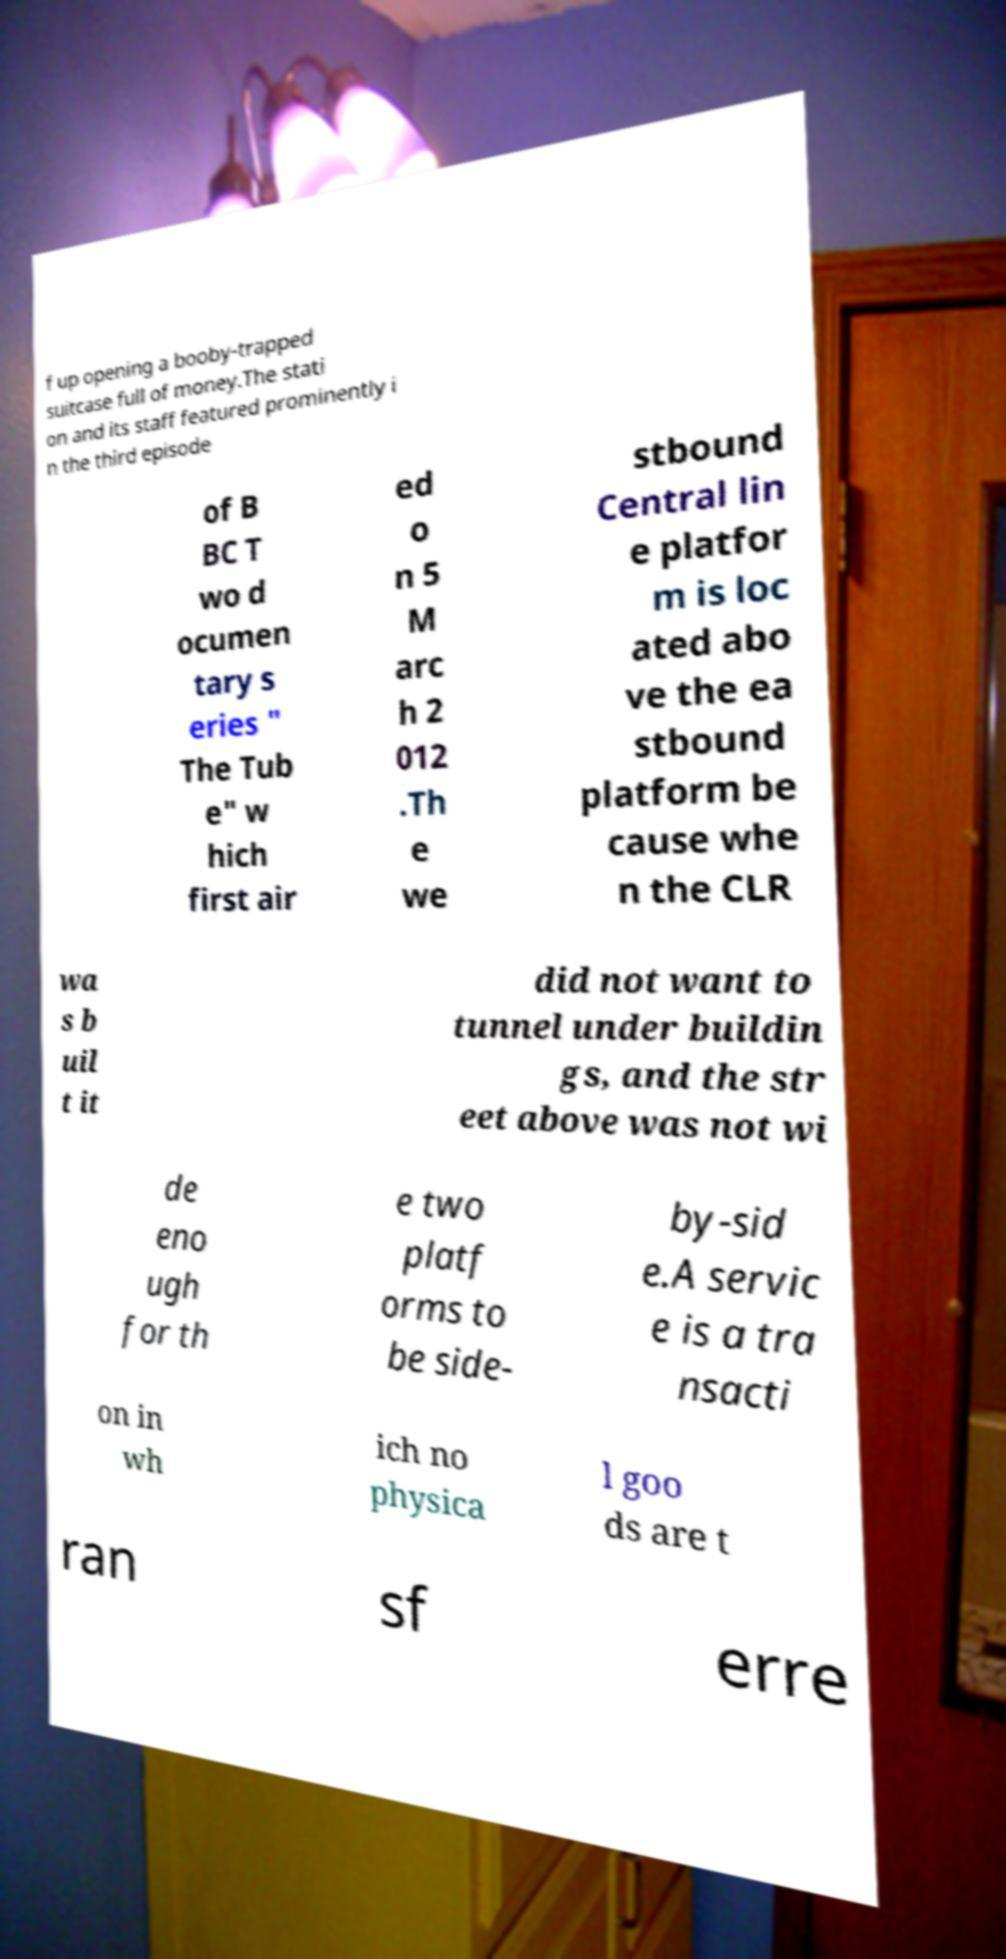Can you read and provide the text displayed in the image?This photo seems to have some interesting text. Can you extract and type it out for me? f up opening a booby-trapped suitcase full of money.The stati on and its staff featured prominently i n the third episode of B BC T wo d ocumen tary s eries " The Tub e" w hich first air ed o n 5 M arc h 2 012 .Th e we stbound Central lin e platfor m is loc ated abo ve the ea stbound platform be cause whe n the CLR wa s b uil t it did not want to tunnel under buildin gs, and the str eet above was not wi de eno ugh for th e two platf orms to be side- by-sid e.A servic e is a tra nsacti on in wh ich no physica l goo ds are t ran sf erre 